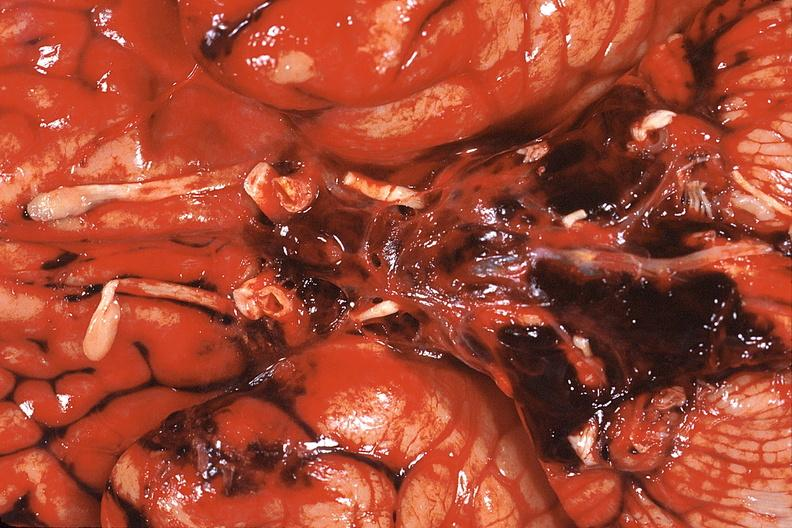s digital infarcts bacterial endocarditis present?
Answer the question using a single word or phrase. No 